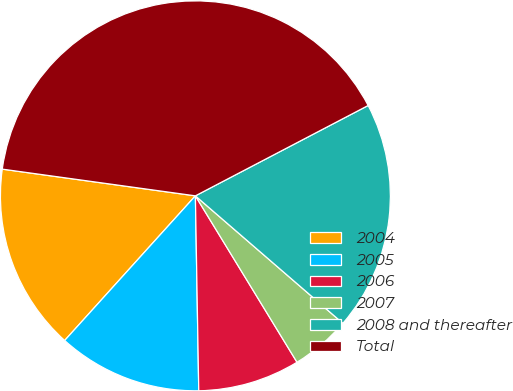Convert chart to OTSL. <chart><loc_0><loc_0><loc_500><loc_500><pie_chart><fcel>2004<fcel>2005<fcel>2006<fcel>2007<fcel>2008 and thereafter<fcel>Total<nl><fcel>15.49%<fcel>11.97%<fcel>8.45%<fcel>4.93%<fcel>19.01%<fcel>40.14%<nl></chart> 